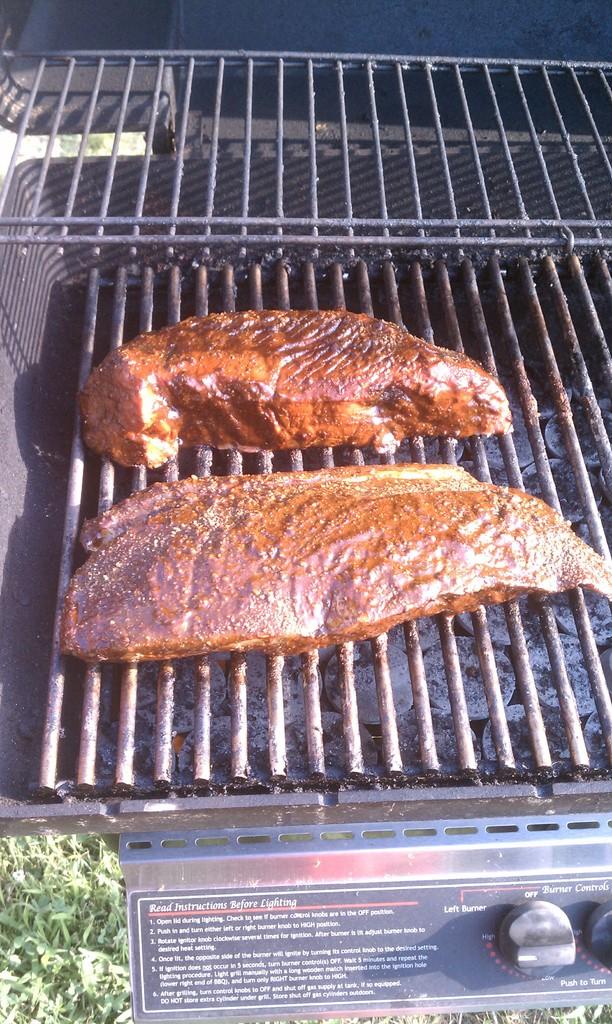What temperature is the grill set to?
Make the answer very short. High. How many pieces of meat are on the grill?
Your answer should be compact. Answering does not require reading text in the image. 